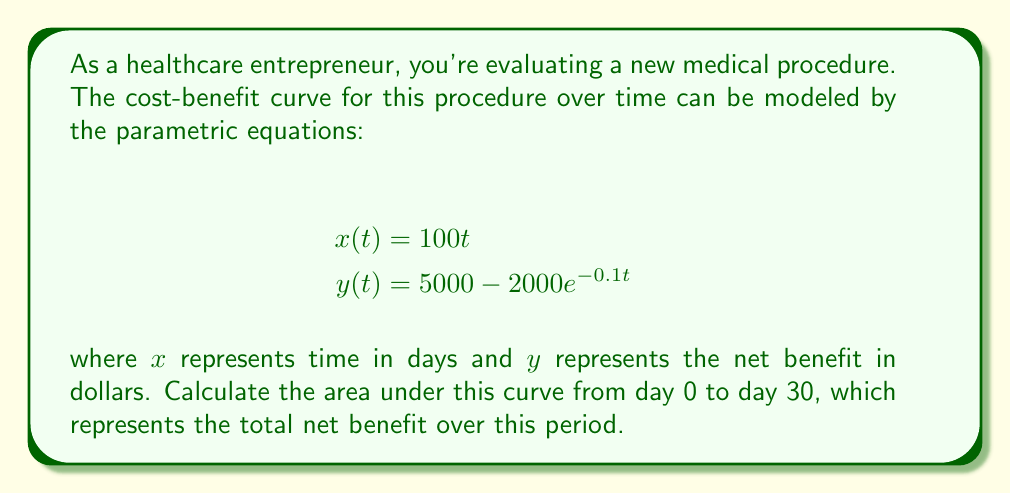What is the answer to this math problem? To find the area under a parametric curve, we can use the formula:

$$\text{Area} = \int_{a}^{b} y(t) \frac{dx}{dt} dt$$

where $a$ and $b$ are the parameter values corresponding to the start and end points.

1) First, we need to find $\frac{dx}{dt}$:
   $$\frac{dx}{dt} = 100$$

2) Now we can set up our integral:
   $$\text{Area} = \int_{0}^{30} (5000 - 2000e^{-0.1t}) \cdot 100 \, dt$$

3) Simplify:
   $$\text{Area} = 100 \int_{0}^{30} (5000 - 2000e^{-0.1t}) \, dt$$

4) Integrate:
   $$\text{Area} = 100 \left[5000t + 20000e^{-0.1t}\right]_{0}^{30}$$

5) Evaluate the definite integral:
   $$\text{Area} = 100 \left[(5000 \cdot 30 + 20000e^{-0.1 \cdot 30}) - (5000 \cdot 0 + 20000e^{-0.1 \cdot 0})\right]$$

6) Simplify:
   $$\text{Area} = 100 \left[150000 + 20000e^{-3} - 20000\right]$$
   $$\text{Area} = 100 \left[150000 + 20000(e^{-3} - 1)\right]$$

7) Calculate the final result:
   $$\text{Area} \approx 14,009,955.76$$
Answer: The area under the cost-benefit curve from day 0 to day 30 is approximately $14,009,955.76, representing the total net benefit in dollars over this period. 